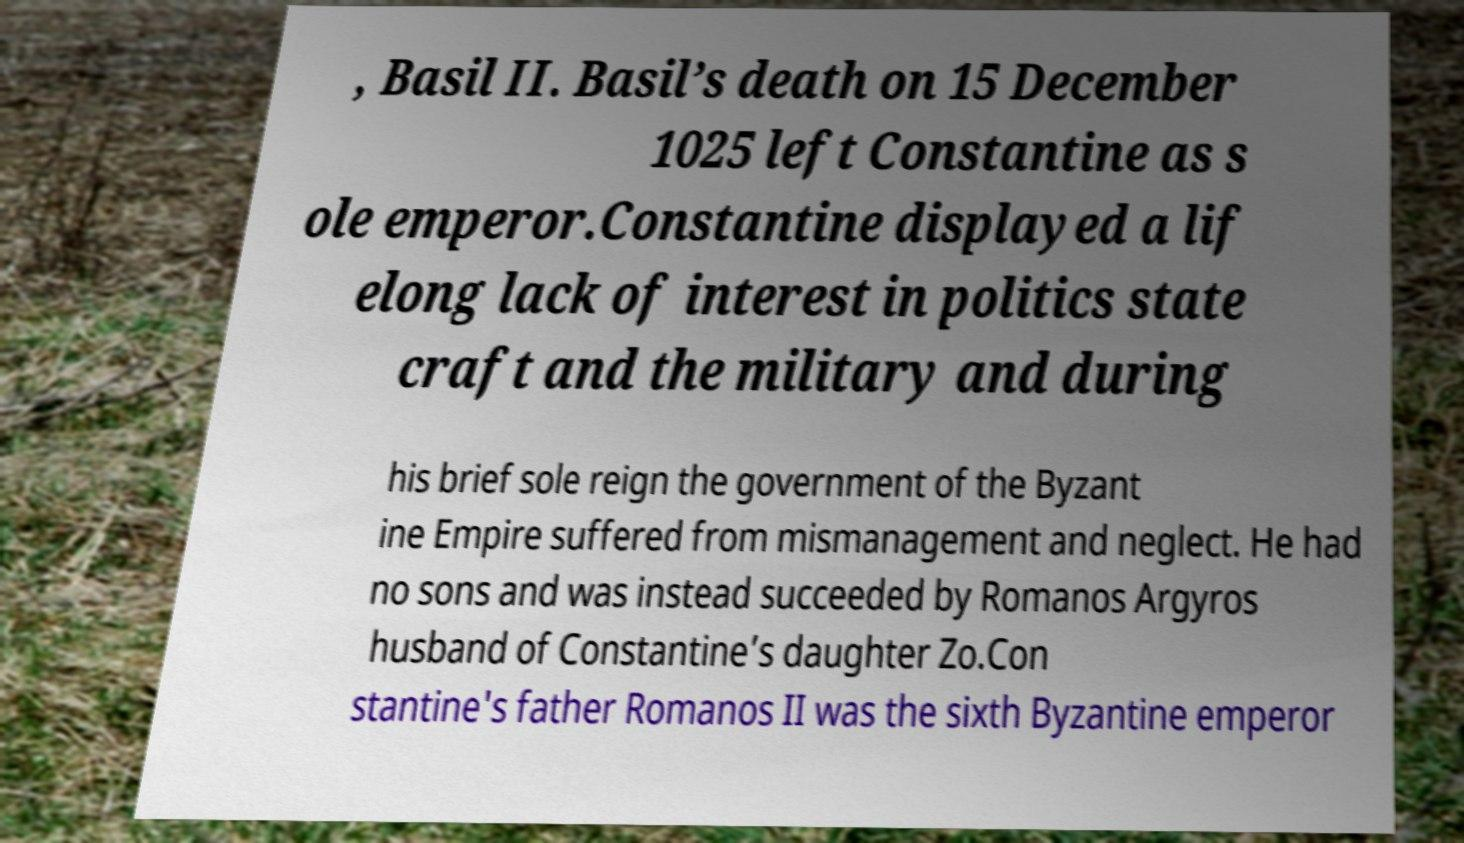I need the written content from this picture converted into text. Can you do that? , Basil II. Basil’s death on 15 December 1025 left Constantine as s ole emperor.Constantine displayed a lif elong lack of interest in politics state craft and the military and during his brief sole reign the government of the Byzant ine Empire suffered from mismanagement and neglect. He had no sons and was instead succeeded by Romanos Argyros husband of Constantine’s daughter Zo.Con stantine's father Romanos II was the sixth Byzantine emperor 